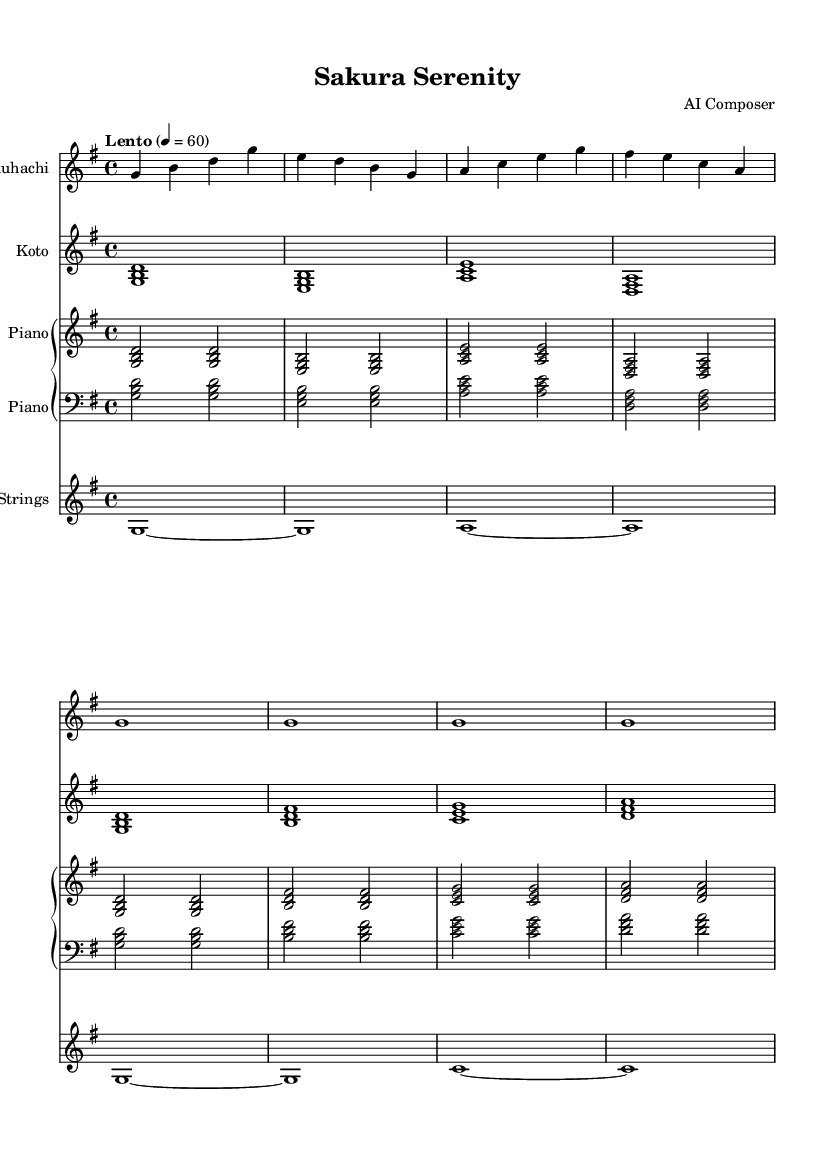What is the key signature of this music? The key signature of this music is G major, which has one sharp (F#). This is identified in the music sheet by the appearance of the F# note in the key signature marking.
Answer: G major What is the time signature of this piece? The time signature is 4/4, represented at the beginning of the score. This indicates that there are four beats in each measure and a quarter note receives one beat.
Answer: 4/4 What is the tempo marking of this piece? The tempo marking reads "Lento" at the beginning, indicating the speed of the piece. "Lento" suggests a slow and relaxed pace, typically around 60 beats per minute, which is also indicated by the metronome mark that follows.
Answer: Lento How many measures does this piece contain? Counting the measures in each staff part, the total number of measures is eight across the entire score. Each instrument part shares the same measure count in this composition.
Answer: Eight What is the instrumental combination used in this composition? The instruments specified in the score are Shakuhachi, Koto, Piano, and Strings. Each of these instruments has its own staff in the score, denoting the unique part they play in the piece.
Answer: Shakuhachi, Koto, Piano, Strings Which instrument plays the melody predominantly? The Shakuhachi primarily plays the melody throughout the piece, as it's the first staff and consists of the main thematic material. The melody is generally characterized by its flow and phrasing seen in the Shakuhachi part.
Answer: Shakuhachi 